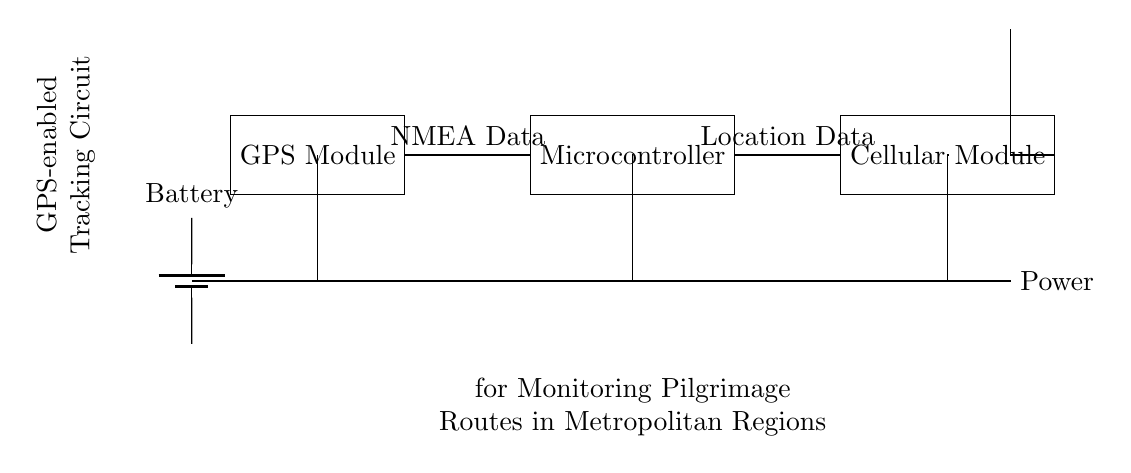What components are in the circuit? The components shown in the circuit include a GPS module, a microcontroller, a cellular module, and a battery. You can identify these by looking at the labeled rectangles in the diagram.
Answer: GPS module, microcontroller, cellular module, battery What does the GPS module output? The GPS module outputs NMEA Data, which is indicated by the label connecting the GPS module to the microcontroller. This data format is a standard used for communication between the GPS device and the microcontroller.
Answer: NMEA Data How is power supplied to the circuit? Power is supplied by a battery, as indicated by the battery symbol in the diagram. The connections from the battery lead to all components, ensuring they receive the necessary voltage to operate.
Answer: Battery What type of data does the microcontroller send to the cellular module? The microcontroller sends location data to the cellular module, as indicated by the label connecting the two components in the circuit. This information is crucial for sending the GPS location to a remote server or application.
Answer: Location Data What is the purpose of the antenna in this circuit? The antenna is used for communication purposes, allowing the cellular module to send data effectively over the network. It's essential for transmitting the location data generated by the microcontroller.
Answer: Communication 